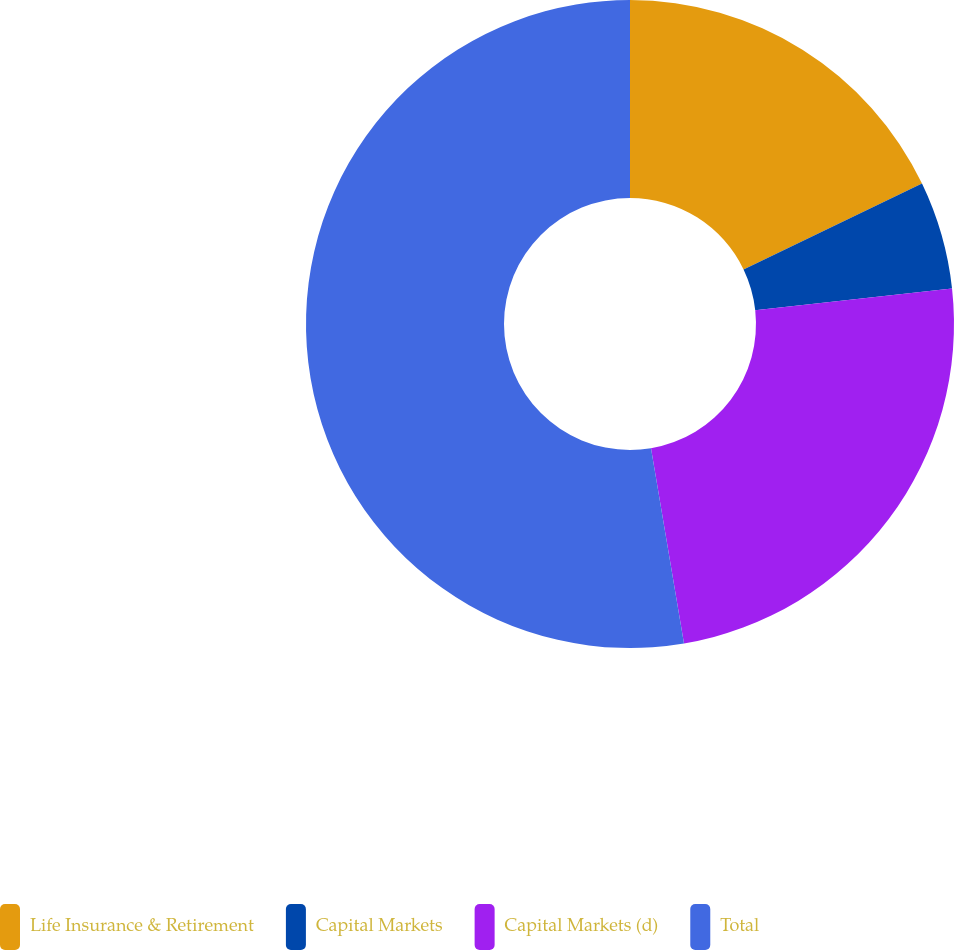<chart> <loc_0><loc_0><loc_500><loc_500><pie_chart><fcel>Life Insurance & Retirement<fcel>Capital Markets<fcel>Capital Markets (d)<fcel>Total<nl><fcel>17.87%<fcel>5.38%<fcel>24.09%<fcel>52.67%<nl></chart> 